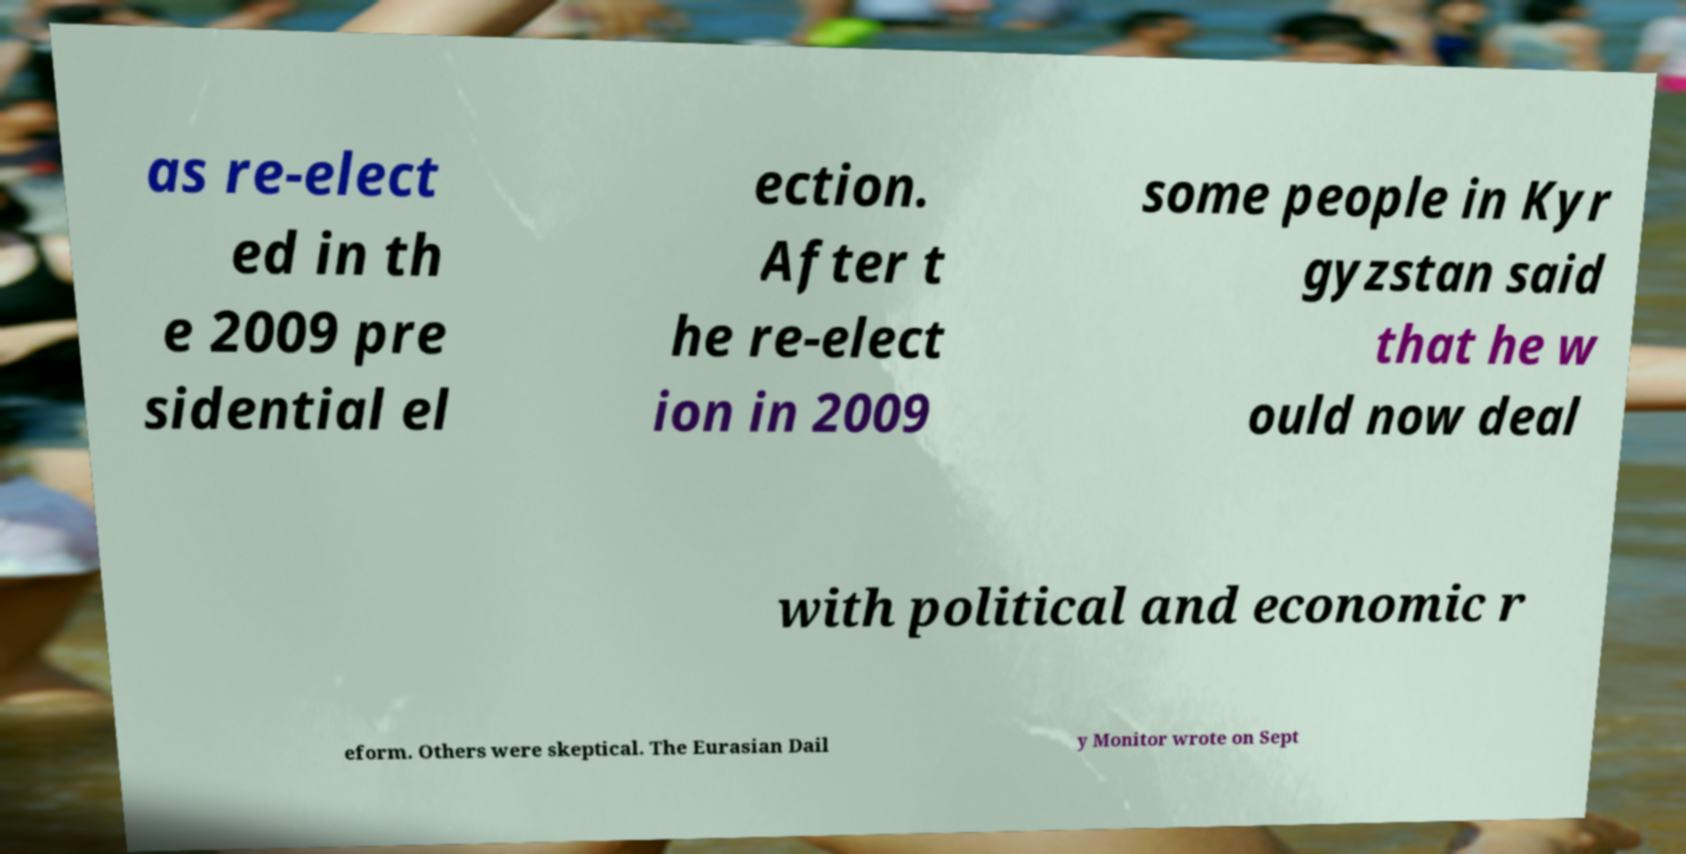Can you accurately transcribe the text from the provided image for me? as re-elect ed in th e 2009 pre sidential el ection. After t he re-elect ion in 2009 some people in Kyr gyzstan said that he w ould now deal with political and economic r eform. Others were skeptical. The Eurasian Dail y Monitor wrote on Sept 